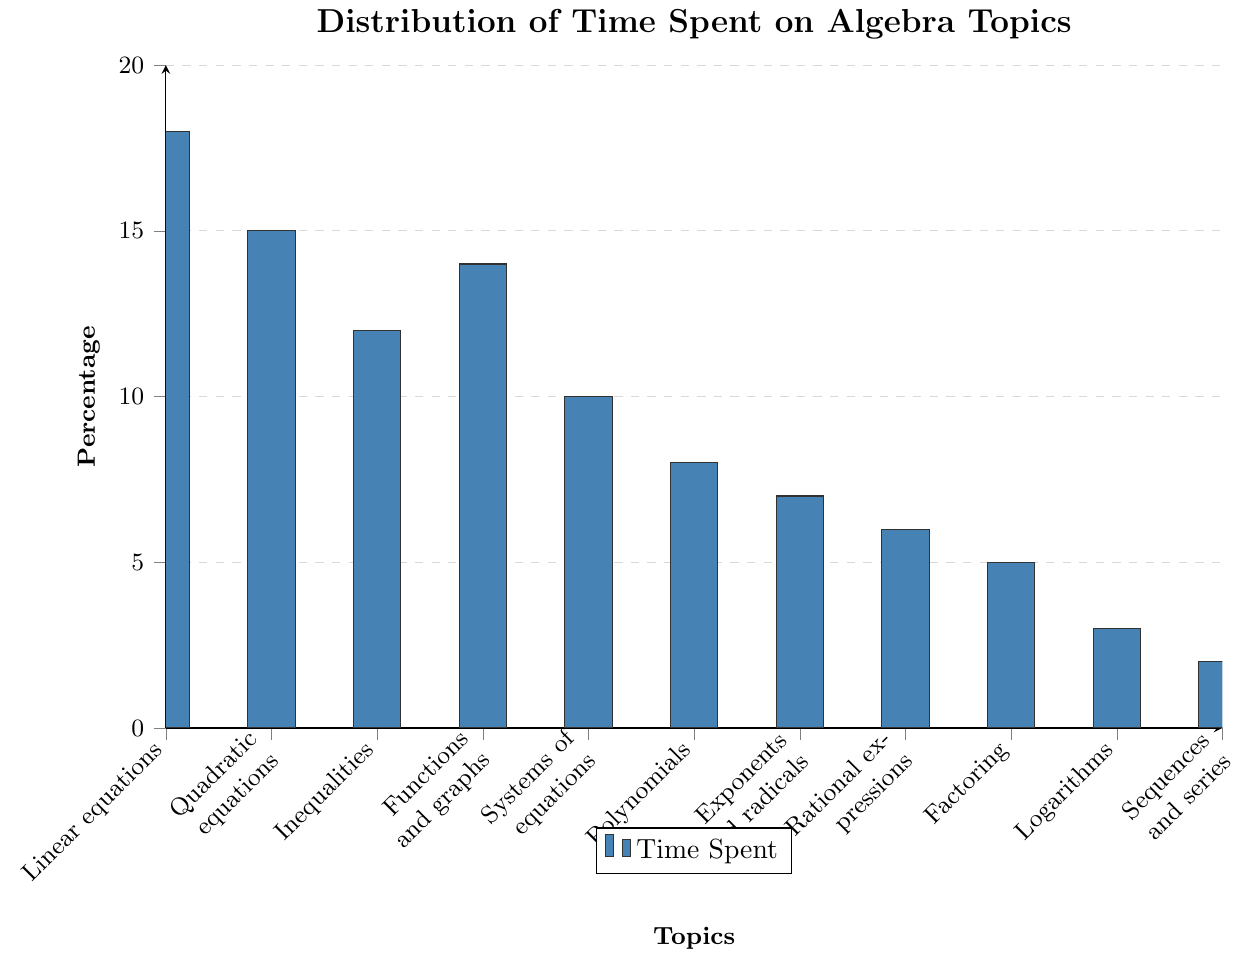What topic has the highest percentage of time spent? The bar chart shows various algebra topics with their corresponding percentages. The tallest bar indicates the highest percentage. By observing, the tallest bar represents "Linear equations" with 18%.
Answer: Linear equations How much more time is spent on Quadratic equations compared to Logarithms? Quadratic equations have a bar with a value of 15%, while Logarithms have 3%. Subtracting these values gives 15% - 3% = 12%.
Answer: 12% What is the combined percentage of time spent on Polynomials and Rational expressions? The bar for Polynomials is at 8%, and for Rational expressions is 6%. Adding these together gives 8% + 6% = 14%.
Answer: 14% Which topic has the lowest percentage of time spent? The bar chart shows the shortest bar represents "Sequences and series" with 2%.
Answer: Sequences and series Compare the time spent on Systems of equations to Functions and graphs. Which one has more time and by how much? Systems of equations have a bar with 10%, while Functions and graphs have 14%. Comparing the two, Functions and graphs have 4% more time.
Answer: Functions and graphs, 4% What is the total percentage of time spent on the topics of Inequalities, Exponents and radicals, and Factoring? Adding the values given by the heights of the bars for these three topics: Inequalities (12%), Exponents and radicals (7%), and Factoring (5%) gives 12% + 7% + 5% = 24%.
Answer: 24% Which two topics have an equal percentage of time spent? By observing the bars of the chart, no two topics share exactly the same height or percentage.
Answer: None Is the percentage of time spent on Linear equations greater than the combined percentage of Logarithms and Sequences and Series? By how much? Linear equations have 18%, Logarithms have 3%, and Sequences and Series have 2%. Adding the latter two gives 3% + 2% = 5%. Subtracting from Linear equations: 18% - 5% = 13%.
Answer: Yes, by 13% What percentage of time is represented by the tallest and shortest bars combined? The tallest bar (Linear equations) is 18%, and the shortest bar (Sequences and series) is 2%. Adding these together: 18% + 2% = 20%.
Answer: 20% Calculate the average percentage of time spent on the ten topics excluding Sequences and series. Excluding Sequences and series, the percentages are 18%, 15%, 12%, 14%, 10%, 8%, 7%, 6%, 5%, and 3%. Adding these together: 18 + 15 + 12 + 14 + 10 + 8 + 7 + 6 + 5 + 3 = 98. Dividing by 10 gives 98 / 10 = 9.8%.
Answer: 9.8% 